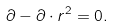<formula> <loc_0><loc_0><loc_500><loc_500>\partial - \partial \cdot r ^ { 2 } = 0 .</formula> 